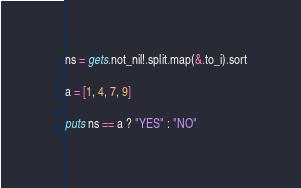<code> <loc_0><loc_0><loc_500><loc_500><_Crystal_>ns = gets.not_nil!.split.map(&.to_i).sort

a = [1, 4, 7, 9]

puts ns == a ? "YES" : "NO"</code> 